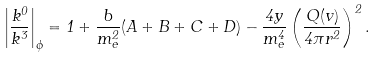<formula> <loc_0><loc_0><loc_500><loc_500>\left | \frac { k ^ { 0 } } { k ^ { 3 } } \right | _ { \phi } = 1 + \frac { b } { m ^ { 2 } _ { e } } ( A + B + C + D ) - \frac { 4 y } { m ^ { 4 } _ { e } } \left ( \frac { Q ( v ) } { 4 \pi r ^ { 2 } } \right ) ^ { 2 } .</formula> 